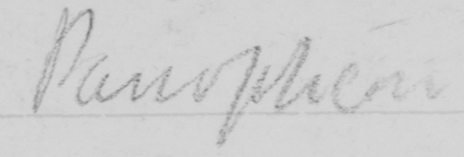What does this handwritten line say? Panopticon 